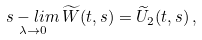Convert formula to latex. <formula><loc_0><loc_0><loc_500><loc_500>\underset { \lambda \to 0 } { s - l i m } \, \widetilde { W } ( t , s ) = \widetilde { U } _ { 2 } ( t , s ) \, ,</formula> 